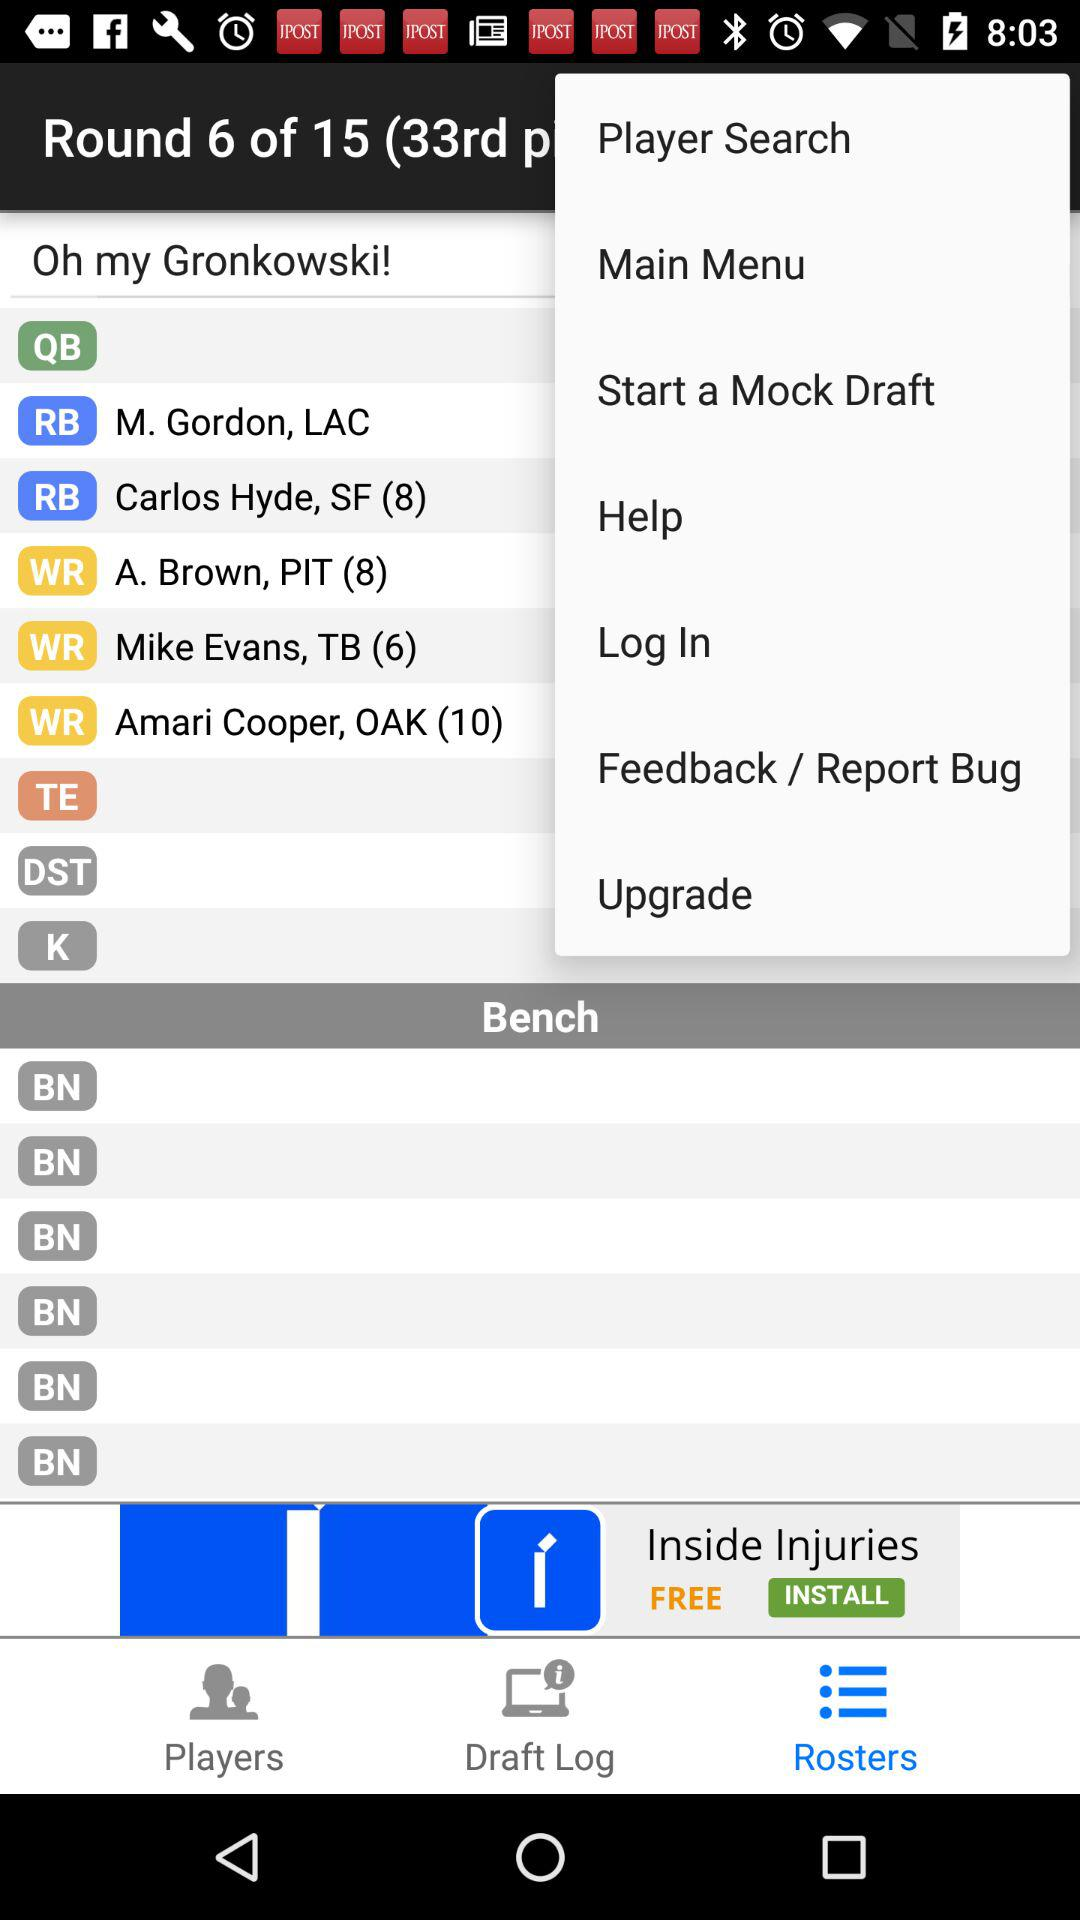How many rounds in total are there? There are 15 rounds in total. 